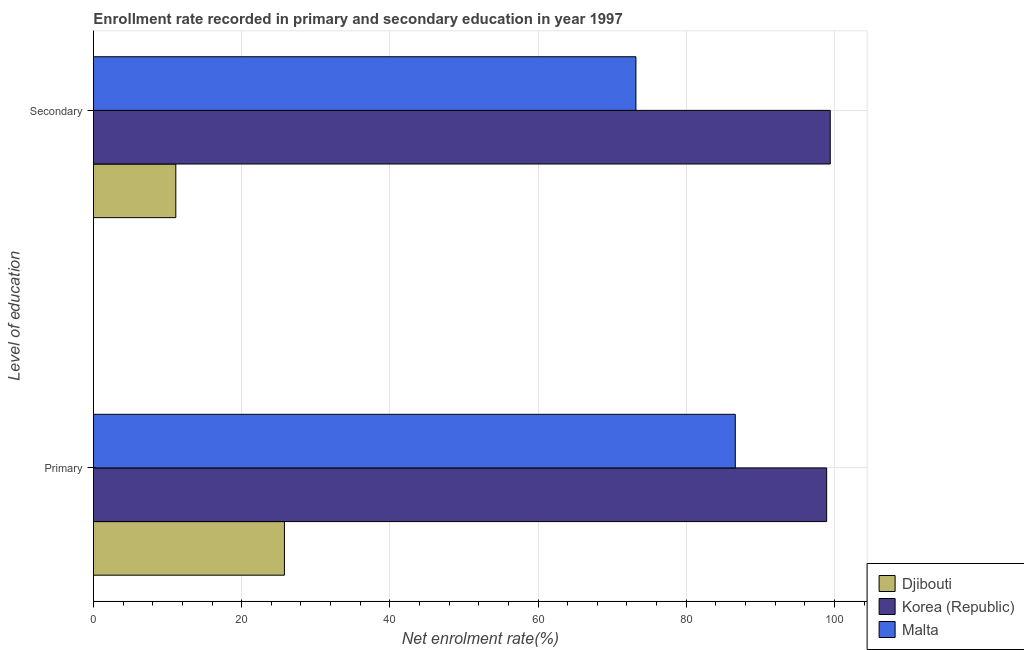How many groups of bars are there?
Provide a succinct answer. 2. Are the number of bars on each tick of the Y-axis equal?
Offer a terse response. Yes. How many bars are there on the 2nd tick from the top?
Your answer should be compact. 3. How many bars are there on the 2nd tick from the bottom?
Your response must be concise. 3. What is the label of the 2nd group of bars from the top?
Your response must be concise. Primary. What is the enrollment rate in primary education in Djibouti?
Your response must be concise. 25.77. Across all countries, what is the maximum enrollment rate in secondary education?
Your response must be concise. 99.43. Across all countries, what is the minimum enrollment rate in secondary education?
Make the answer very short. 11.11. In which country was the enrollment rate in secondary education minimum?
Your answer should be very brief. Djibouti. What is the total enrollment rate in primary education in the graph?
Your answer should be compact. 211.34. What is the difference between the enrollment rate in primary education in Malta and that in Djibouti?
Provide a short and direct response. 60.85. What is the difference between the enrollment rate in secondary education in Djibouti and the enrollment rate in primary education in Malta?
Make the answer very short. -75.51. What is the average enrollment rate in secondary education per country?
Keep it short and to the point. 61.25. What is the difference between the enrollment rate in secondary education and enrollment rate in primary education in Djibouti?
Your answer should be very brief. -14.66. In how many countries, is the enrollment rate in primary education greater than 4 %?
Keep it short and to the point. 3. What is the ratio of the enrollment rate in secondary education in Djibouti to that in Malta?
Ensure brevity in your answer.  0.15. Is the enrollment rate in secondary education in Djibouti less than that in Korea (Republic)?
Provide a succinct answer. Yes. In how many countries, is the enrollment rate in primary education greater than the average enrollment rate in primary education taken over all countries?
Offer a very short reply. 2. What does the 3rd bar from the top in Primary represents?
Make the answer very short. Djibouti. What does the 3rd bar from the bottom in Primary represents?
Provide a succinct answer. Malta. What is the difference between two consecutive major ticks on the X-axis?
Your answer should be very brief. 20. Are the values on the major ticks of X-axis written in scientific E-notation?
Your answer should be compact. No. Does the graph contain any zero values?
Offer a very short reply. No. Where does the legend appear in the graph?
Ensure brevity in your answer.  Bottom right. How are the legend labels stacked?
Provide a short and direct response. Vertical. What is the title of the graph?
Keep it short and to the point. Enrollment rate recorded in primary and secondary education in year 1997. What is the label or title of the X-axis?
Your answer should be very brief. Net enrolment rate(%). What is the label or title of the Y-axis?
Offer a very short reply. Level of education. What is the Net enrolment rate(%) in Djibouti in Primary?
Provide a short and direct response. 25.77. What is the Net enrolment rate(%) of Korea (Republic) in Primary?
Provide a short and direct response. 98.95. What is the Net enrolment rate(%) of Malta in Primary?
Your response must be concise. 86.62. What is the Net enrolment rate(%) in Djibouti in Secondary?
Offer a terse response. 11.11. What is the Net enrolment rate(%) of Korea (Republic) in Secondary?
Offer a terse response. 99.43. What is the Net enrolment rate(%) of Malta in Secondary?
Offer a very short reply. 73.21. Across all Level of education, what is the maximum Net enrolment rate(%) in Djibouti?
Your answer should be compact. 25.77. Across all Level of education, what is the maximum Net enrolment rate(%) of Korea (Republic)?
Your answer should be compact. 99.43. Across all Level of education, what is the maximum Net enrolment rate(%) of Malta?
Give a very brief answer. 86.62. Across all Level of education, what is the minimum Net enrolment rate(%) of Djibouti?
Give a very brief answer. 11.11. Across all Level of education, what is the minimum Net enrolment rate(%) in Korea (Republic)?
Make the answer very short. 98.95. Across all Level of education, what is the minimum Net enrolment rate(%) of Malta?
Provide a succinct answer. 73.21. What is the total Net enrolment rate(%) of Djibouti in the graph?
Offer a terse response. 36.88. What is the total Net enrolment rate(%) in Korea (Republic) in the graph?
Make the answer very short. 198.38. What is the total Net enrolment rate(%) in Malta in the graph?
Ensure brevity in your answer.  159.83. What is the difference between the Net enrolment rate(%) of Djibouti in Primary and that in Secondary?
Your response must be concise. 14.66. What is the difference between the Net enrolment rate(%) of Korea (Republic) in Primary and that in Secondary?
Your response must be concise. -0.49. What is the difference between the Net enrolment rate(%) in Malta in Primary and that in Secondary?
Provide a succinct answer. 13.41. What is the difference between the Net enrolment rate(%) of Djibouti in Primary and the Net enrolment rate(%) of Korea (Republic) in Secondary?
Your answer should be very brief. -73.66. What is the difference between the Net enrolment rate(%) in Djibouti in Primary and the Net enrolment rate(%) in Malta in Secondary?
Offer a very short reply. -47.44. What is the difference between the Net enrolment rate(%) in Korea (Republic) in Primary and the Net enrolment rate(%) in Malta in Secondary?
Make the answer very short. 25.74. What is the average Net enrolment rate(%) of Djibouti per Level of education?
Ensure brevity in your answer.  18.44. What is the average Net enrolment rate(%) in Korea (Republic) per Level of education?
Offer a very short reply. 99.19. What is the average Net enrolment rate(%) of Malta per Level of education?
Provide a short and direct response. 79.91. What is the difference between the Net enrolment rate(%) of Djibouti and Net enrolment rate(%) of Korea (Republic) in Primary?
Ensure brevity in your answer.  -73.18. What is the difference between the Net enrolment rate(%) in Djibouti and Net enrolment rate(%) in Malta in Primary?
Your answer should be compact. -60.85. What is the difference between the Net enrolment rate(%) of Korea (Republic) and Net enrolment rate(%) of Malta in Primary?
Your answer should be very brief. 12.33. What is the difference between the Net enrolment rate(%) in Djibouti and Net enrolment rate(%) in Korea (Republic) in Secondary?
Provide a succinct answer. -88.32. What is the difference between the Net enrolment rate(%) of Djibouti and Net enrolment rate(%) of Malta in Secondary?
Your answer should be very brief. -62.1. What is the difference between the Net enrolment rate(%) in Korea (Republic) and Net enrolment rate(%) in Malta in Secondary?
Offer a terse response. 26.23. What is the ratio of the Net enrolment rate(%) in Djibouti in Primary to that in Secondary?
Give a very brief answer. 2.32. What is the ratio of the Net enrolment rate(%) of Malta in Primary to that in Secondary?
Your answer should be compact. 1.18. What is the difference between the highest and the second highest Net enrolment rate(%) of Djibouti?
Your response must be concise. 14.66. What is the difference between the highest and the second highest Net enrolment rate(%) in Korea (Republic)?
Give a very brief answer. 0.49. What is the difference between the highest and the second highest Net enrolment rate(%) in Malta?
Keep it short and to the point. 13.41. What is the difference between the highest and the lowest Net enrolment rate(%) in Djibouti?
Ensure brevity in your answer.  14.66. What is the difference between the highest and the lowest Net enrolment rate(%) of Korea (Republic)?
Give a very brief answer. 0.49. What is the difference between the highest and the lowest Net enrolment rate(%) in Malta?
Ensure brevity in your answer.  13.41. 